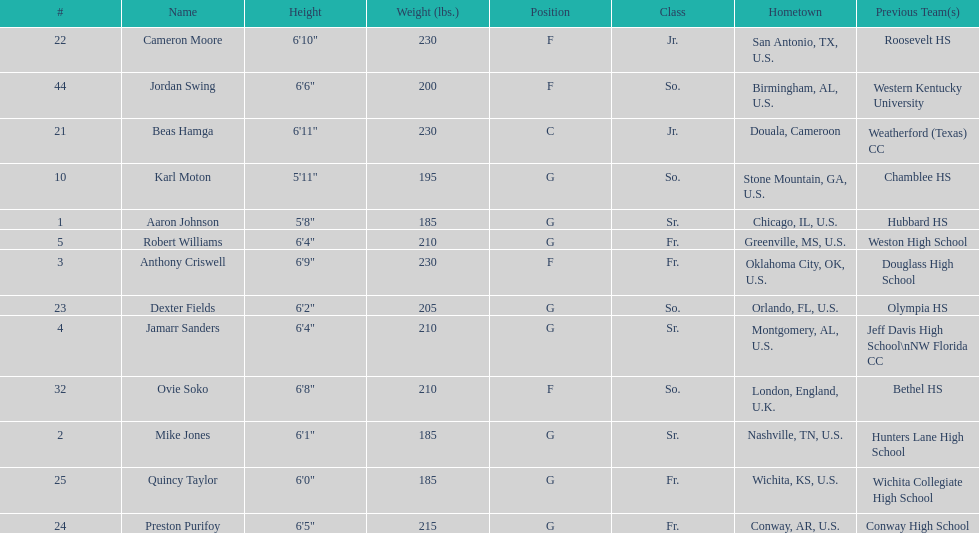What is the difference in weight between dexter fields and quincy taylor? 20. 